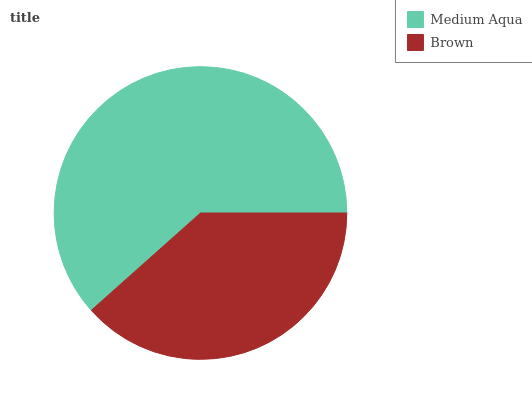Is Brown the minimum?
Answer yes or no. Yes. Is Medium Aqua the maximum?
Answer yes or no. Yes. Is Brown the maximum?
Answer yes or no. No. Is Medium Aqua greater than Brown?
Answer yes or no. Yes. Is Brown less than Medium Aqua?
Answer yes or no. Yes. Is Brown greater than Medium Aqua?
Answer yes or no. No. Is Medium Aqua less than Brown?
Answer yes or no. No. Is Medium Aqua the high median?
Answer yes or no. Yes. Is Brown the low median?
Answer yes or no. Yes. Is Brown the high median?
Answer yes or no. No. Is Medium Aqua the low median?
Answer yes or no. No. 